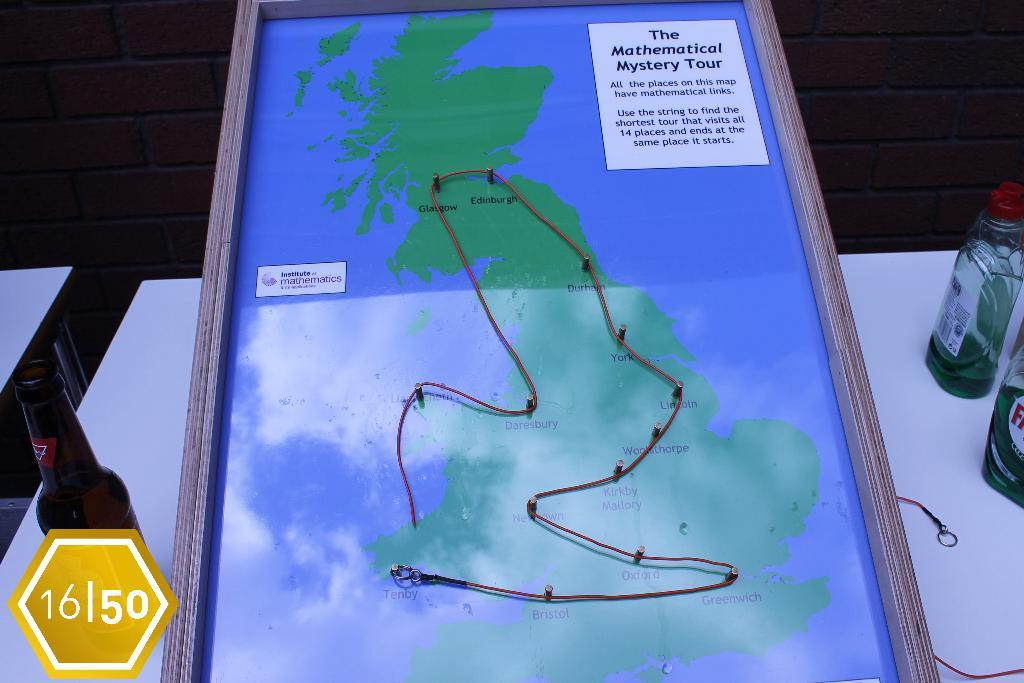<image>
Write a terse but informative summary of the picture. A map of the Mathematical Mystery Tour in the UK is shown. 